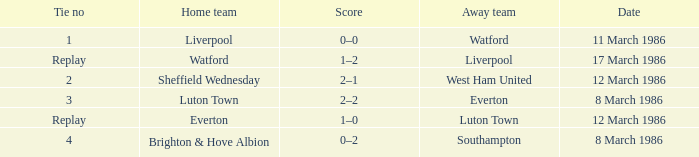Who was the home team in the match against Luton Town? Everton. 